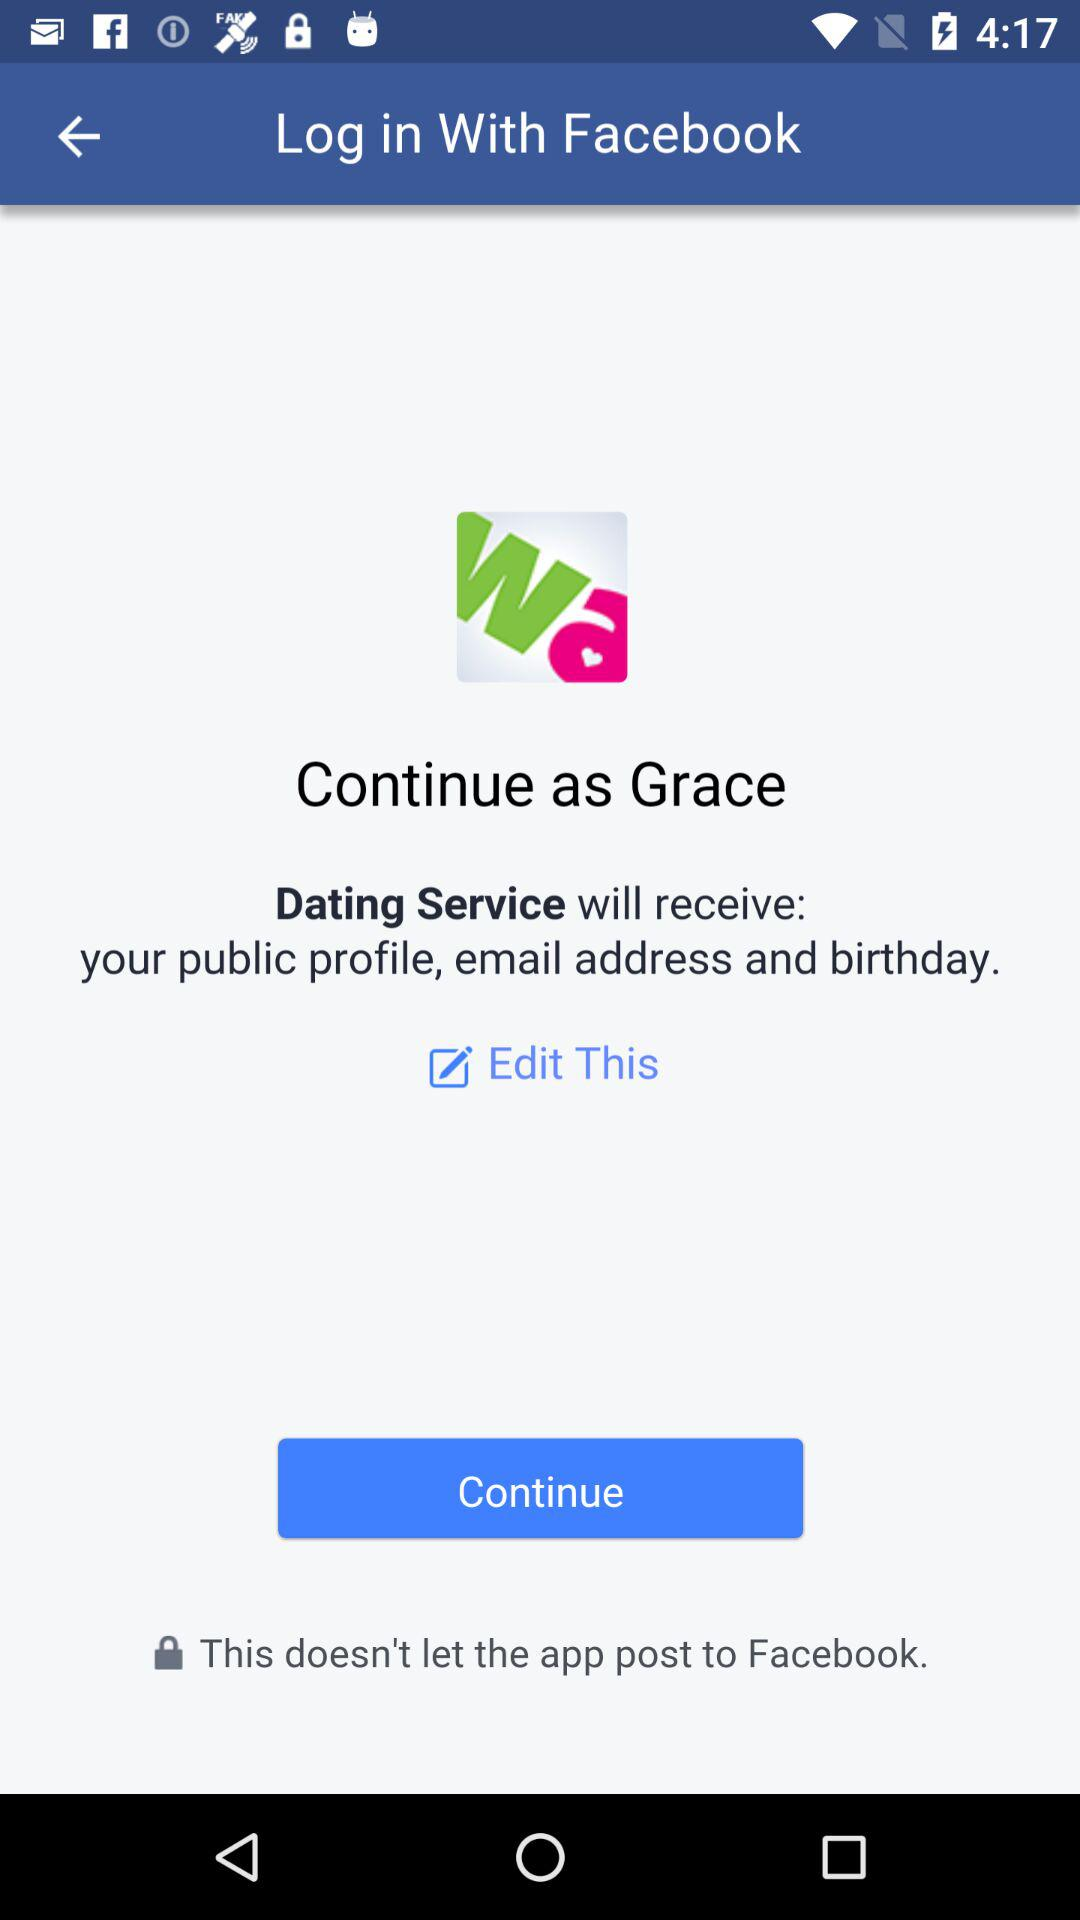Through what application can we log in? You can login with "Facebook". 